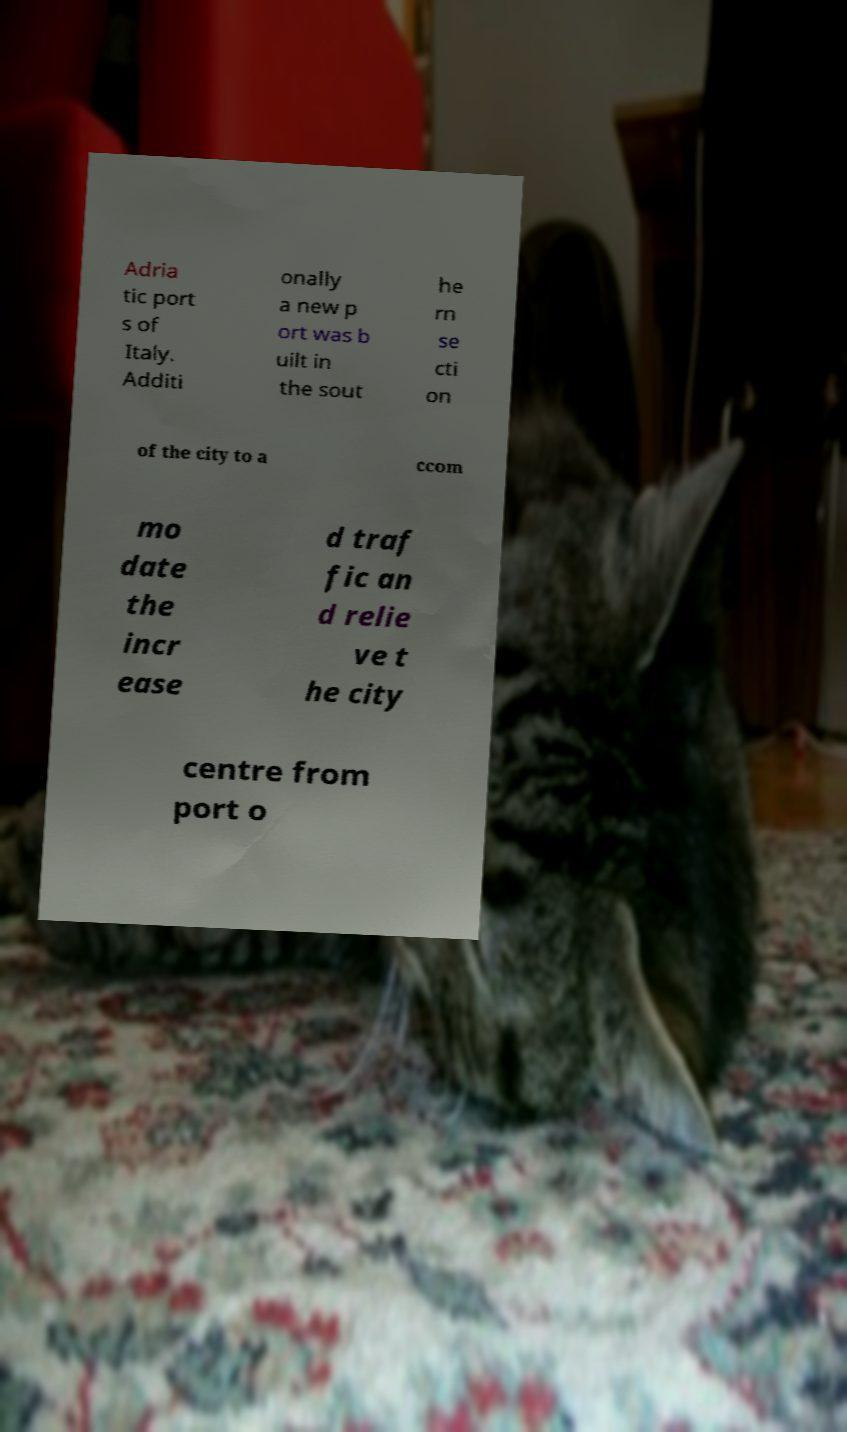There's text embedded in this image that I need extracted. Can you transcribe it verbatim? Adria tic port s of Italy. Additi onally a new p ort was b uilt in the sout he rn se cti on of the city to a ccom mo date the incr ease d traf fic an d relie ve t he city centre from port o 